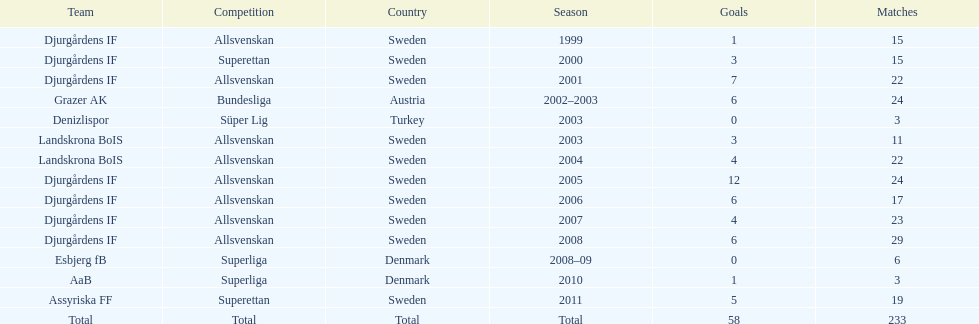Give me the full table as a dictionary. {'header': ['Team', 'Competition', 'Country', 'Season', 'Goals', 'Matches'], 'rows': [['Djurgårdens IF', 'Allsvenskan', 'Sweden', '1999', '1', '15'], ['Djurgårdens IF', 'Superettan', 'Sweden', '2000', '3', '15'], ['Djurgårdens IF', 'Allsvenskan', 'Sweden', '2001', '7', '22'], ['Grazer AK', 'Bundesliga', 'Austria', '2002–2003', '6', '24'], ['Denizlispor', 'Süper Lig', 'Turkey', '2003', '0', '3'], ['Landskrona BoIS', 'Allsvenskan', 'Sweden', '2003', '3', '11'], ['Landskrona BoIS', 'Allsvenskan', 'Sweden', '2004', '4', '22'], ['Djurgårdens IF', 'Allsvenskan', 'Sweden', '2005', '12', '24'], ['Djurgårdens IF', 'Allsvenskan', 'Sweden', '2006', '6', '17'], ['Djurgårdens IF', 'Allsvenskan', 'Sweden', '2007', '4', '23'], ['Djurgårdens IF', 'Allsvenskan', 'Sweden', '2008', '6', '29'], ['Esbjerg fB', 'Superliga', 'Denmark', '2008–09', '0', '6'], ['AaB', 'Superliga', 'Denmark', '2010', '1', '3'], ['Assyriska FF', 'Superettan', 'Sweden', '2011', '5', '19'], ['Total', 'Total', 'Total', 'Total', '58', '233']]} What team has the most goals? Djurgårdens IF. 